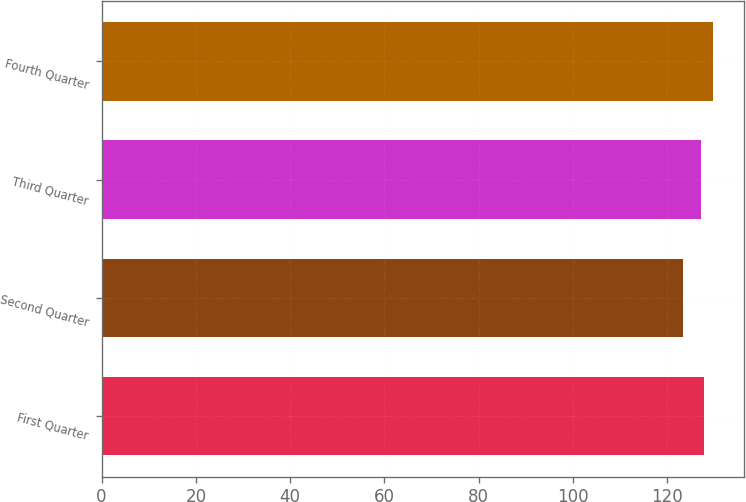<chart> <loc_0><loc_0><loc_500><loc_500><bar_chart><fcel>First Quarter<fcel>Second Quarter<fcel>Third Quarter<fcel>Fourth Quarter<nl><fcel>127.85<fcel>123.37<fcel>127.21<fcel>129.77<nl></chart> 